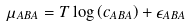<formula> <loc_0><loc_0><loc_500><loc_500>\mu _ { A B A } = T \log \left ( c _ { A B A } \right ) + \epsilon _ { A B A }</formula> 